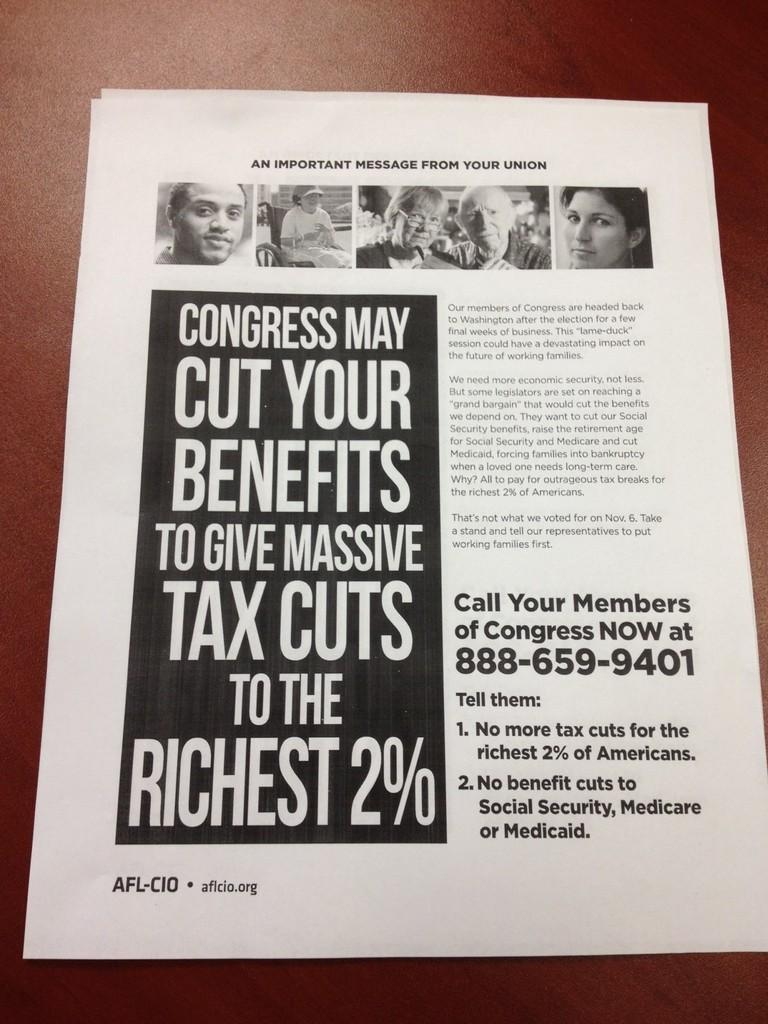What is the color of the papers in the image? The papers in the image are white. How many papers are there in the image? There are two papers in the image. Is there any writing on the papers? Yes, something is written on one of the papers. What can be seen on the paper with writing? There are pictures of people on the paper with writing. What type of slope can be seen in the background of the image? There is no slope visible in the image; it features two white color papers with writing and pictures of people. 